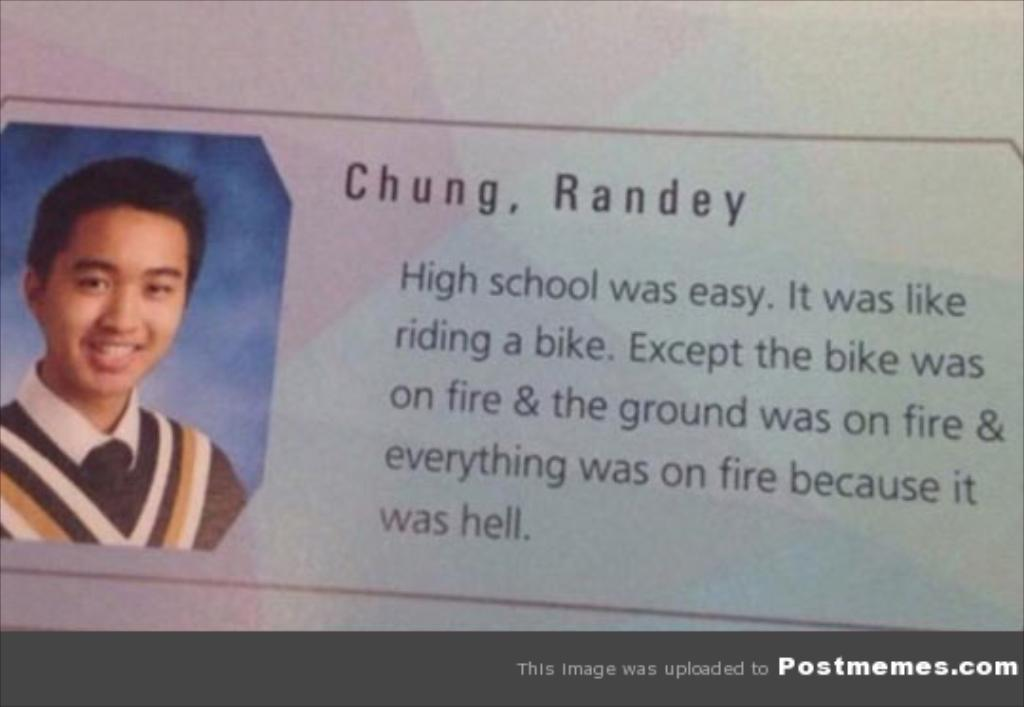What is the main subject of the image? There is a photo of a person in the center of the image. Are there any words or phrases in the image? Yes, there is some text in the image. What can be seen at the bottom of the image? There is a border at the bottom of the image. What reason does the person in the image give for starting a war? There is no mention of war or any reasons in the image; it only features a photo of a person and some text. 